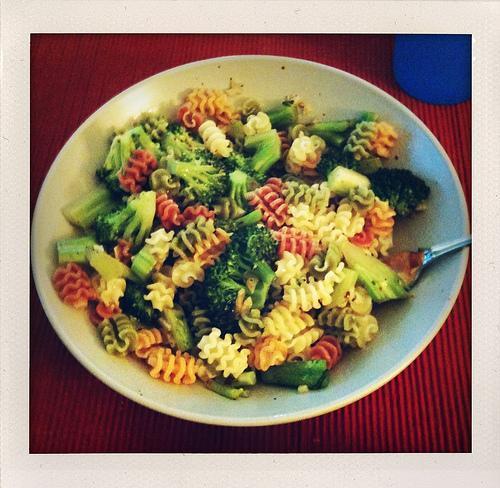What is in the bowl?
Pick the correct solution from the four options below to address the question.
Options: Beef stew, pasta, apples, pizza. Pasta. 